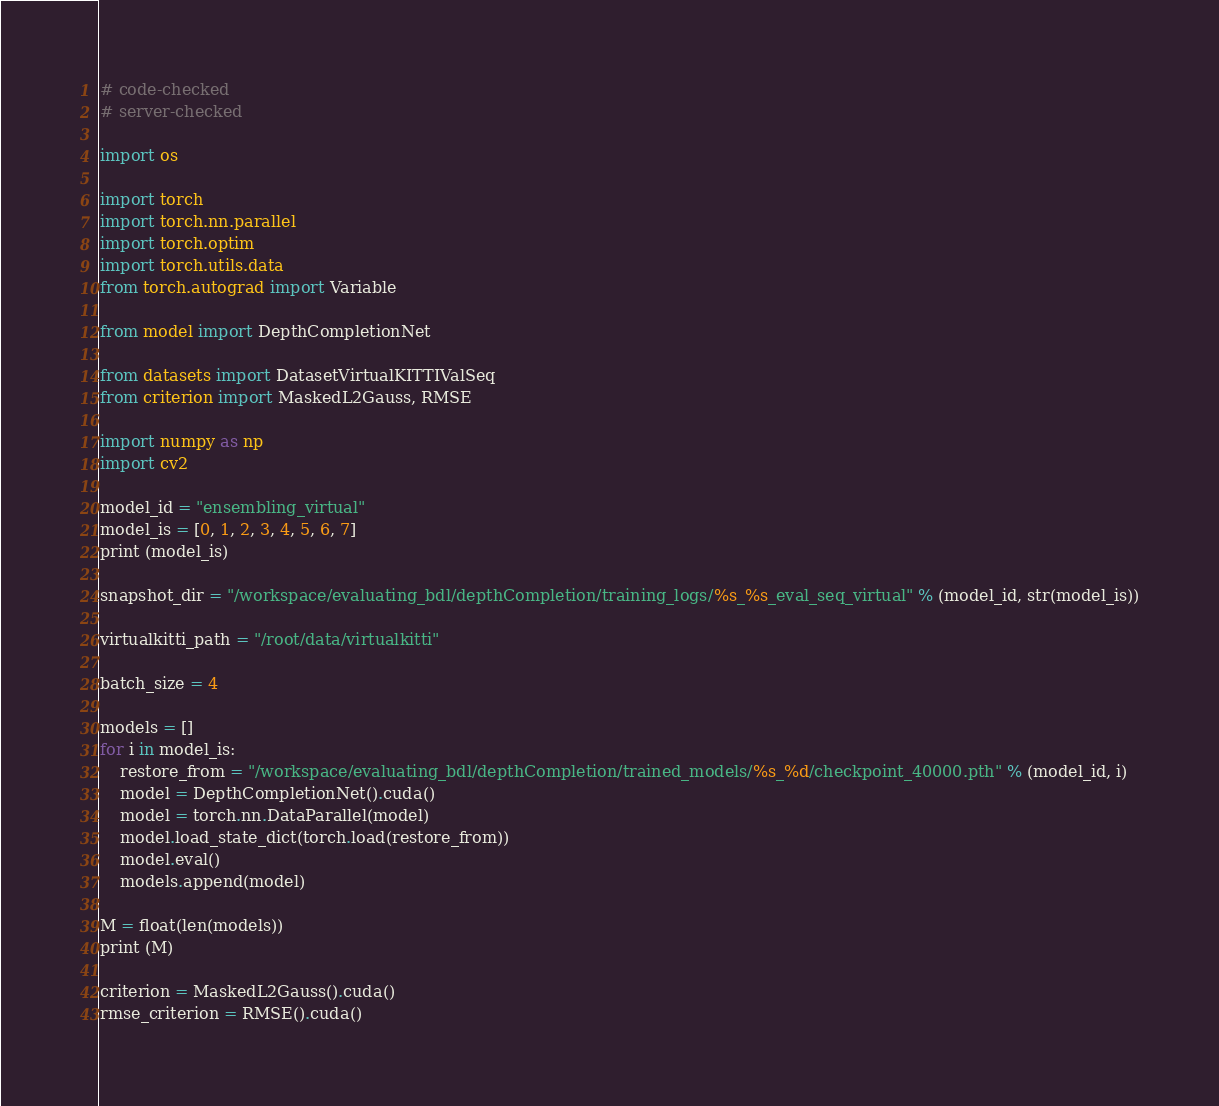<code> <loc_0><loc_0><loc_500><loc_500><_Python_># code-checked
# server-checked

import os

import torch
import torch.nn.parallel
import torch.optim
import torch.utils.data
from torch.autograd import Variable

from model import DepthCompletionNet

from datasets import DatasetVirtualKITTIValSeq
from criterion import MaskedL2Gauss, RMSE

import numpy as np
import cv2

model_id = "ensembling_virtual"
model_is = [0, 1, 2, 3, 4, 5, 6, 7]
print (model_is)

snapshot_dir = "/workspace/evaluating_bdl/depthCompletion/training_logs/%s_%s_eval_seq_virtual" % (model_id, str(model_is))

virtualkitti_path = "/root/data/virtualkitti"

batch_size = 4

models = []
for i in model_is:
    restore_from = "/workspace/evaluating_bdl/depthCompletion/trained_models/%s_%d/checkpoint_40000.pth" % (model_id, i)
    model = DepthCompletionNet().cuda()
    model = torch.nn.DataParallel(model)
    model.load_state_dict(torch.load(restore_from))
    model.eval()
    models.append(model)

M = float(len(models))
print (M)

criterion = MaskedL2Gauss().cuda()
rmse_criterion = RMSE().cuda()
</code> 